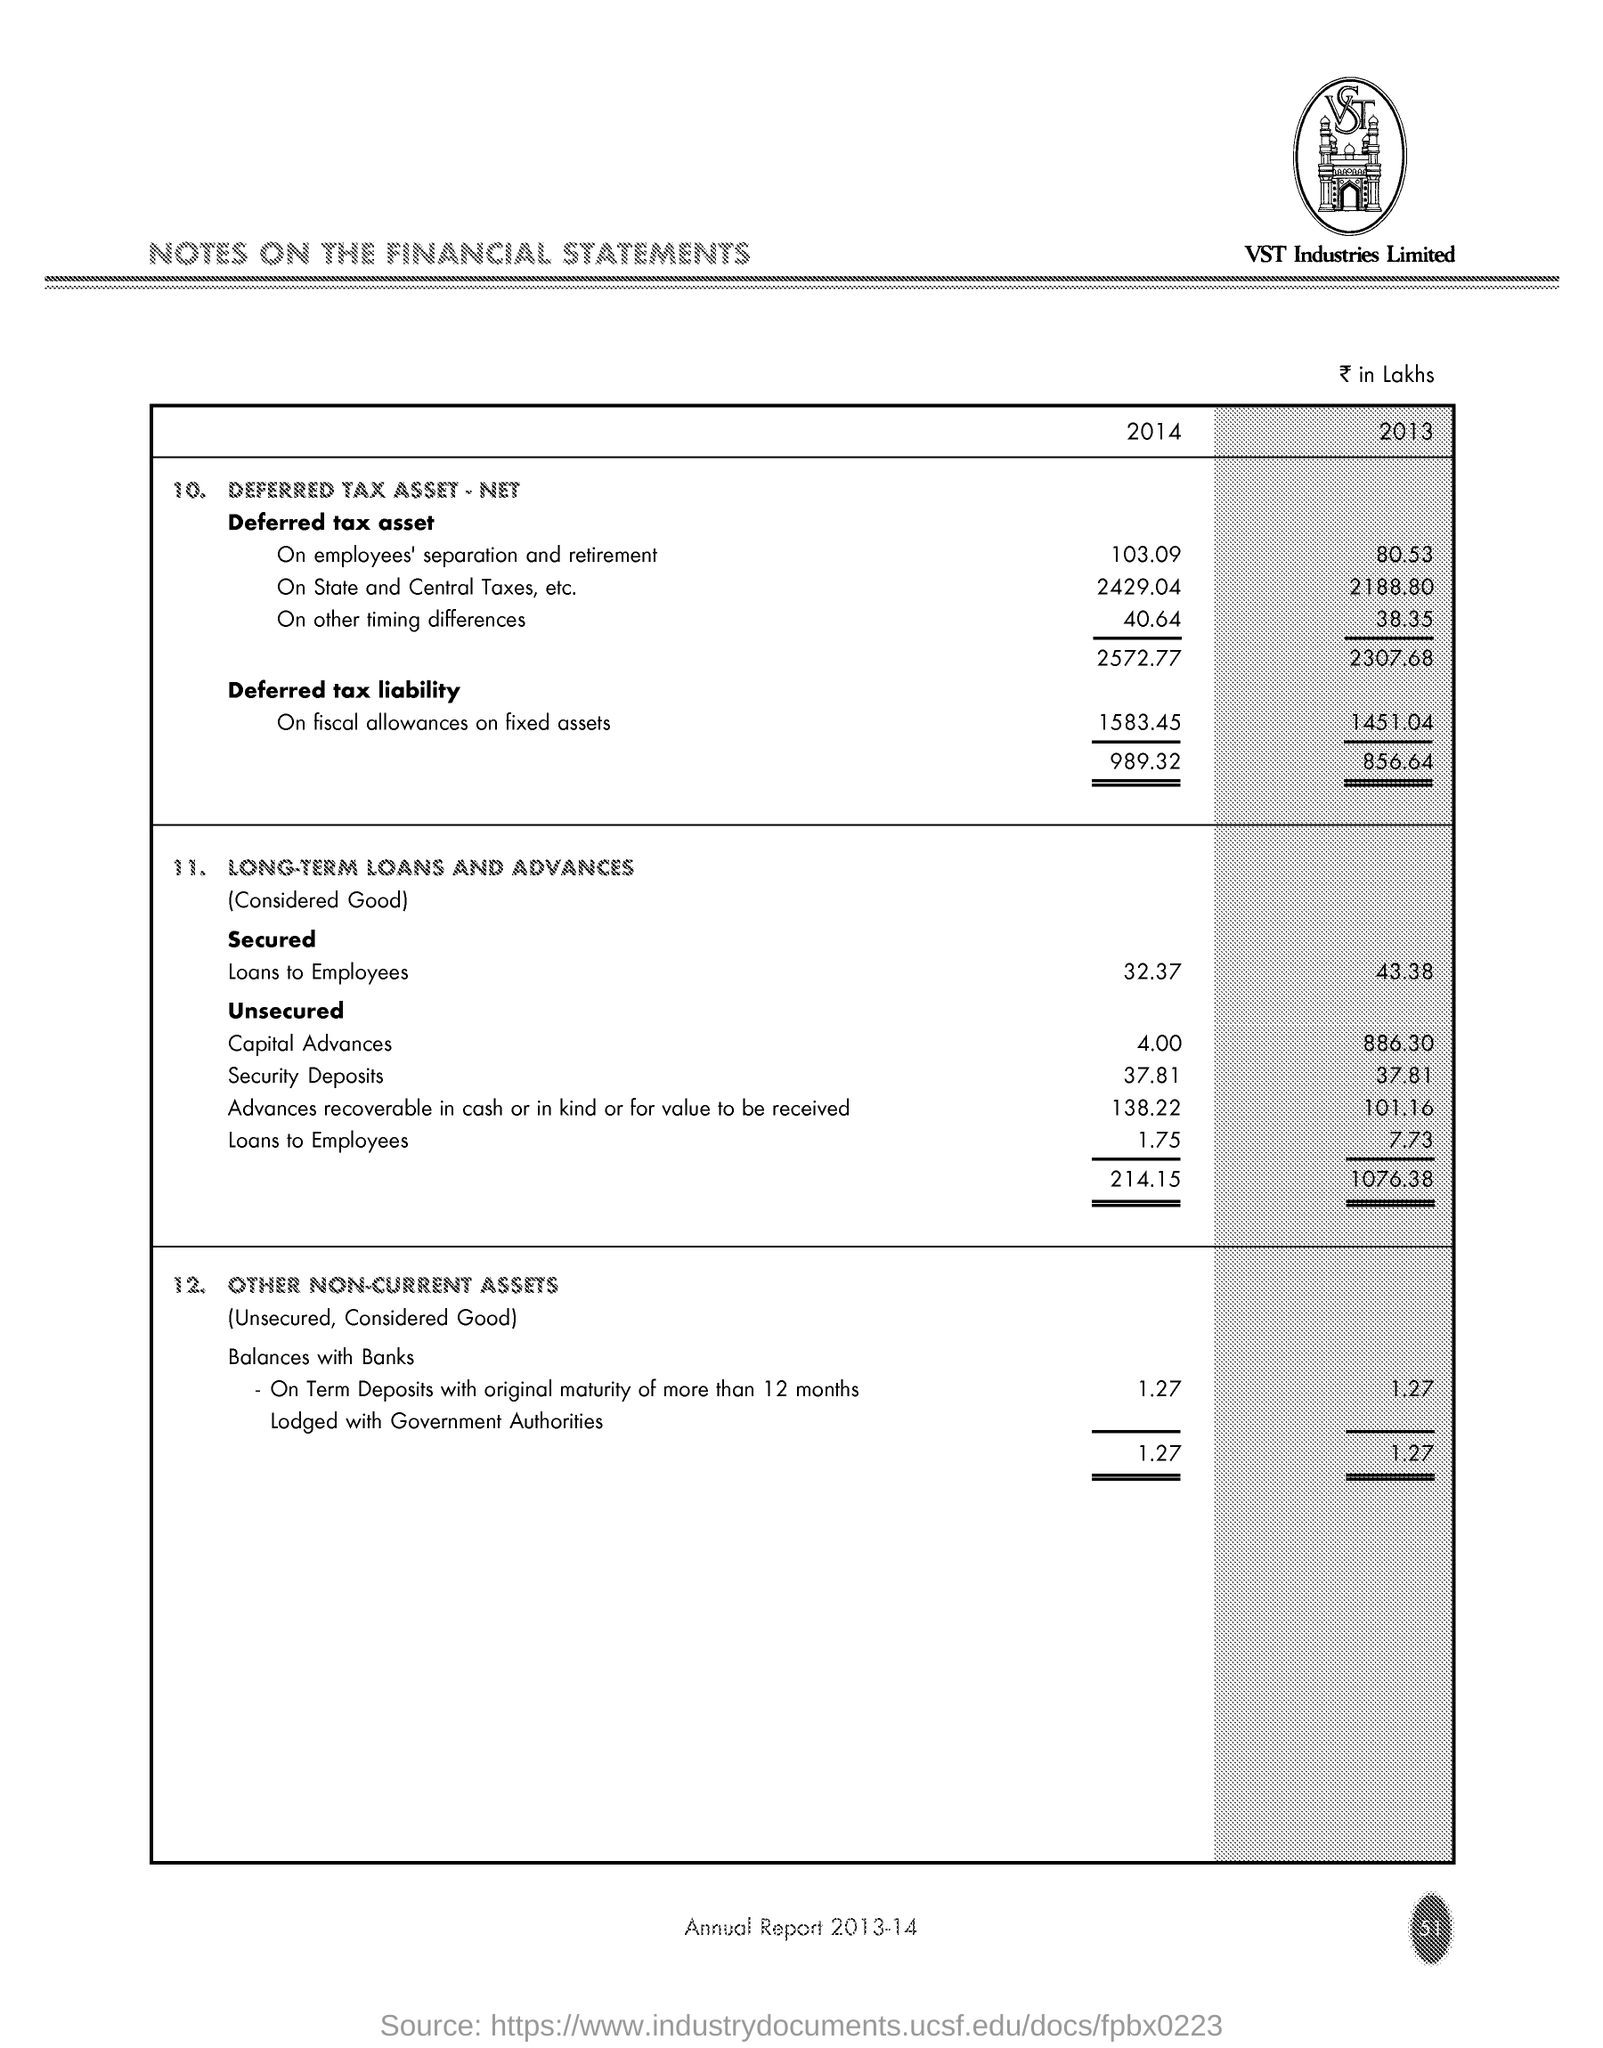Which company's name is at the top of the page?
Offer a terse response. VST Industries Limited. What is the document about?
Your response must be concise. NOTES ON THE FINANCIAL STATEMENTS. What is the amount of Secured Loans to Employees for the year 2013 in Rs in Lakhs?
Offer a terse response. 43.38. For which year is this Annual Report?
Provide a succinct answer. 2013-14. 